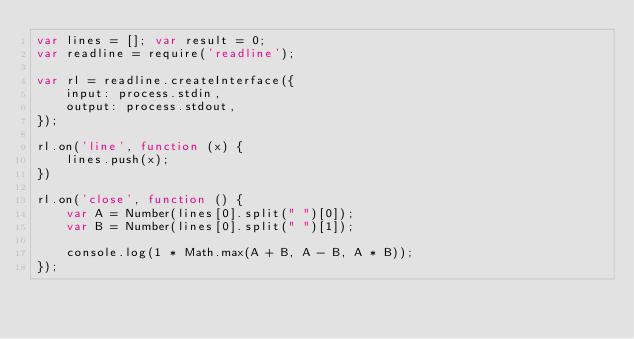<code> <loc_0><loc_0><loc_500><loc_500><_JavaScript_>var lines = []; var result = 0;
var readline = require('readline');

var rl = readline.createInterface({
    input: process.stdin,
    output: process.stdout,
});

rl.on('line', function (x) {
    lines.push(x);
})

rl.on('close', function () {
    var A = Number(lines[0].split(" ")[0]);
    var B = Number(lines[0].split(" ")[1]);

    console.log(1 * Math.max(A + B, A - B, A * B));
});</code> 